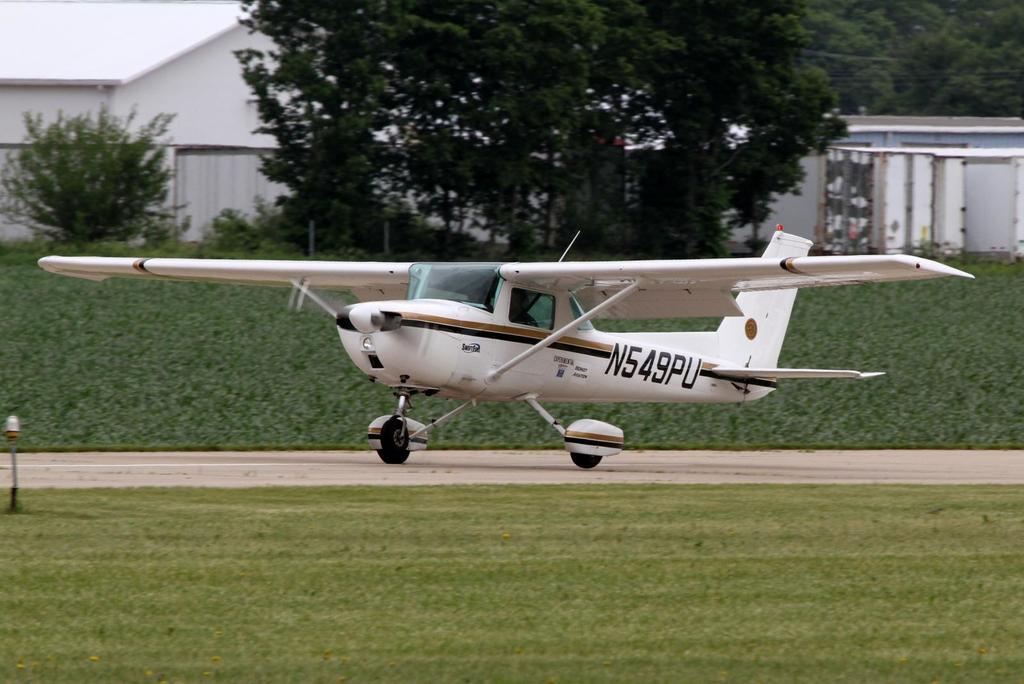What is the number of this small plane?
Your answer should be compact. N549pu. 